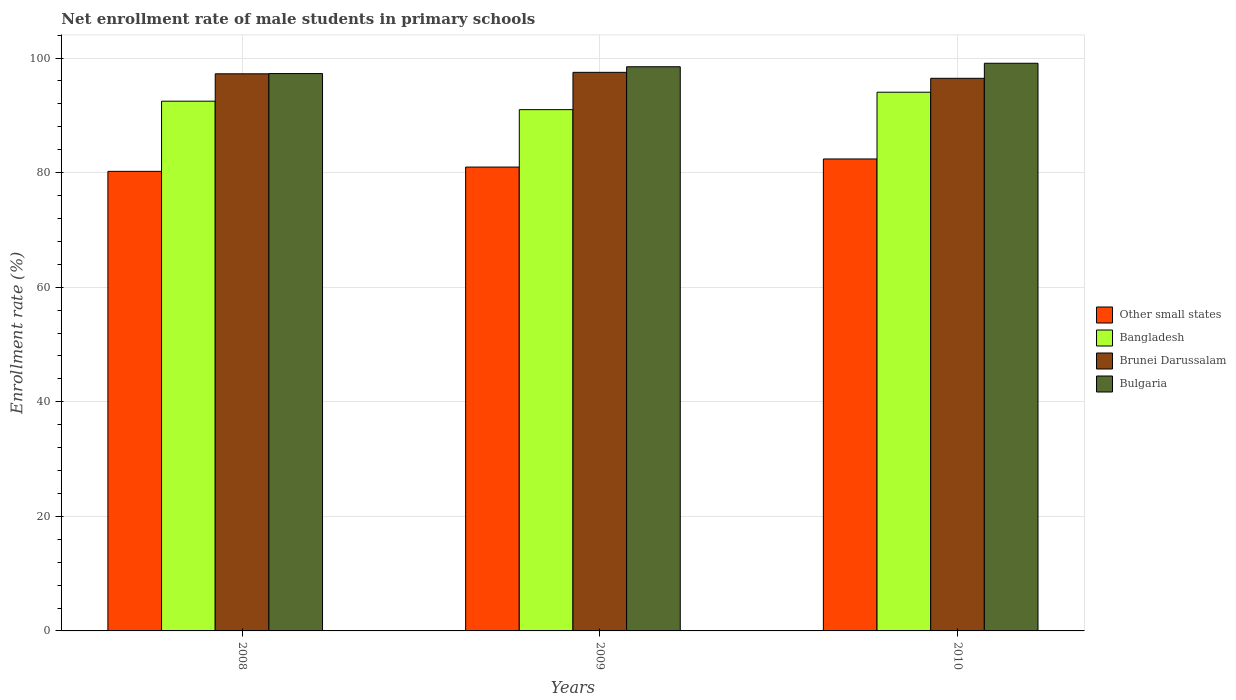How many different coloured bars are there?
Ensure brevity in your answer.  4. How many groups of bars are there?
Keep it short and to the point. 3. Are the number of bars per tick equal to the number of legend labels?
Your response must be concise. Yes. How many bars are there on the 1st tick from the right?
Ensure brevity in your answer.  4. What is the label of the 1st group of bars from the left?
Your response must be concise. 2008. What is the net enrollment rate of male students in primary schools in Bulgaria in 2009?
Give a very brief answer. 98.48. Across all years, what is the maximum net enrollment rate of male students in primary schools in Bangladesh?
Provide a succinct answer. 94.03. Across all years, what is the minimum net enrollment rate of male students in primary schools in Brunei Darussalam?
Provide a short and direct response. 96.46. In which year was the net enrollment rate of male students in primary schools in Bulgaria maximum?
Ensure brevity in your answer.  2010. In which year was the net enrollment rate of male students in primary schools in Bangladesh minimum?
Provide a short and direct response. 2009. What is the total net enrollment rate of male students in primary schools in Bulgaria in the graph?
Your response must be concise. 294.85. What is the difference between the net enrollment rate of male students in primary schools in Bulgaria in 2008 and that in 2010?
Your answer should be compact. -1.8. What is the difference between the net enrollment rate of male students in primary schools in Brunei Darussalam in 2008 and the net enrollment rate of male students in primary schools in Bulgaria in 2009?
Give a very brief answer. -1.23. What is the average net enrollment rate of male students in primary schools in Bulgaria per year?
Provide a short and direct response. 98.28. In the year 2009, what is the difference between the net enrollment rate of male students in primary schools in Bulgaria and net enrollment rate of male students in primary schools in Other small states?
Offer a terse response. 17.51. In how many years, is the net enrollment rate of male students in primary schools in Brunei Darussalam greater than 72 %?
Offer a terse response. 3. What is the ratio of the net enrollment rate of male students in primary schools in Bulgaria in 2008 to that in 2009?
Your response must be concise. 0.99. Is the difference between the net enrollment rate of male students in primary schools in Bulgaria in 2008 and 2010 greater than the difference between the net enrollment rate of male students in primary schools in Other small states in 2008 and 2010?
Make the answer very short. Yes. What is the difference between the highest and the second highest net enrollment rate of male students in primary schools in Bangladesh?
Provide a succinct answer. 1.57. What is the difference between the highest and the lowest net enrollment rate of male students in primary schools in Brunei Darussalam?
Your answer should be very brief. 1.04. In how many years, is the net enrollment rate of male students in primary schools in Bulgaria greater than the average net enrollment rate of male students in primary schools in Bulgaria taken over all years?
Ensure brevity in your answer.  2. Is the sum of the net enrollment rate of male students in primary schools in Bulgaria in 2008 and 2009 greater than the maximum net enrollment rate of male students in primary schools in Other small states across all years?
Keep it short and to the point. Yes. What does the 2nd bar from the left in 2009 represents?
Your answer should be compact. Bangladesh. What does the 1st bar from the right in 2010 represents?
Your answer should be very brief. Bulgaria. Is it the case that in every year, the sum of the net enrollment rate of male students in primary schools in Bulgaria and net enrollment rate of male students in primary schools in Bangladesh is greater than the net enrollment rate of male students in primary schools in Other small states?
Your response must be concise. Yes. How many bars are there?
Provide a succinct answer. 12. What is the difference between two consecutive major ticks on the Y-axis?
Keep it short and to the point. 20. Does the graph contain grids?
Ensure brevity in your answer.  Yes. Where does the legend appear in the graph?
Keep it short and to the point. Center right. How many legend labels are there?
Ensure brevity in your answer.  4. How are the legend labels stacked?
Provide a short and direct response. Vertical. What is the title of the graph?
Offer a very short reply. Net enrollment rate of male students in primary schools. Does "Faeroe Islands" appear as one of the legend labels in the graph?
Your response must be concise. No. What is the label or title of the X-axis?
Provide a succinct answer. Years. What is the label or title of the Y-axis?
Provide a succinct answer. Enrollment rate (%). What is the Enrollment rate (%) of Other small states in 2008?
Your answer should be compact. 80.22. What is the Enrollment rate (%) in Bangladesh in 2008?
Give a very brief answer. 92.47. What is the Enrollment rate (%) of Brunei Darussalam in 2008?
Make the answer very short. 97.25. What is the Enrollment rate (%) of Bulgaria in 2008?
Provide a succinct answer. 97.29. What is the Enrollment rate (%) in Other small states in 2009?
Offer a very short reply. 80.97. What is the Enrollment rate (%) in Bangladesh in 2009?
Provide a succinct answer. 90.99. What is the Enrollment rate (%) in Brunei Darussalam in 2009?
Provide a short and direct response. 97.5. What is the Enrollment rate (%) in Bulgaria in 2009?
Your answer should be compact. 98.48. What is the Enrollment rate (%) in Other small states in 2010?
Ensure brevity in your answer.  82.38. What is the Enrollment rate (%) in Bangladesh in 2010?
Your answer should be compact. 94.03. What is the Enrollment rate (%) of Brunei Darussalam in 2010?
Your answer should be very brief. 96.46. What is the Enrollment rate (%) in Bulgaria in 2010?
Your answer should be compact. 99.09. Across all years, what is the maximum Enrollment rate (%) of Other small states?
Make the answer very short. 82.38. Across all years, what is the maximum Enrollment rate (%) in Bangladesh?
Make the answer very short. 94.03. Across all years, what is the maximum Enrollment rate (%) of Brunei Darussalam?
Give a very brief answer. 97.5. Across all years, what is the maximum Enrollment rate (%) in Bulgaria?
Your answer should be compact. 99.09. Across all years, what is the minimum Enrollment rate (%) in Other small states?
Your answer should be very brief. 80.22. Across all years, what is the minimum Enrollment rate (%) in Bangladesh?
Provide a short and direct response. 90.99. Across all years, what is the minimum Enrollment rate (%) in Brunei Darussalam?
Ensure brevity in your answer.  96.46. Across all years, what is the minimum Enrollment rate (%) in Bulgaria?
Give a very brief answer. 97.29. What is the total Enrollment rate (%) of Other small states in the graph?
Offer a terse response. 243.57. What is the total Enrollment rate (%) in Bangladesh in the graph?
Provide a succinct answer. 277.49. What is the total Enrollment rate (%) in Brunei Darussalam in the graph?
Ensure brevity in your answer.  291.21. What is the total Enrollment rate (%) of Bulgaria in the graph?
Make the answer very short. 294.85. What is the difference between the Enrollment rate (%) in Other small states in 2008 and that in 2009?
Ensure brevity in your answer.  -0.75. What is the difference between the Enrollment rate (%) of Bangladesh in 2008 and that in 2009?
Offer a very short reply. 1.48. What is the difference between the Enrollment rate (%) in Brunei Darussalam in 2008 and that in 2009?
Keep it short and to the point. -0.26. What is the difference between the Enrollment rate (%) in Bulgaria in 2008 and that in 2009?
Your answer should be very brief. -1.19. What is the difference between the Enrollment rate (%) in Other small states in 2008 and that in 2010?
Provide a short and direct response. -2.16. What is the difference between the Enrollment rate (%) in Bangladesh in 2008 and that in 2010?
Offer a very short reply. -1.57. What is the difference between the Enrollment rate (%) in Brunei Darussalam in 2008 and that in 2010?
Your response must be concise. 0.79. What is the difference between the Enrollment rate (%) of Bulgaria in 2008 and that in 2010?
Ensure brevity in your answer.  -1.8. What is the difference between the Enrollment rate (%) of Other small states in 2009 and that in 2010?
Give a very brief answer. -1.41. What is the difference between the Enrollment rate (%) of Bangladesh in 2009 and that in 2010?
Provide a succinct answer. -3.05. What is the difference between the Enrollment rate (%) in Brunei Darussalam in 2009 and that in 2010?
Keep it short and to the point. 1.04. What is the difference between the Enrollment rate (%) of Bulgaria in 2009 and that in 2010?
Offer a very short reply. -0.61. What is the difference between the Enrollment rate (%) of Other small states in 2008 and the Enrollment rate (%) of Bangladesh in 2009?
Your response must be concise. -10.77. What is the difference between the Enrollment rate (%) in Other small states in 2008 and the Enrollment rate (%) in Brunei Darussalam in 2009?
Provide a short and direct response. -17.29. What is the difference between the Enrollment rate (%) of Other small states in 2008 and the Enrollment rate (%) of Bulgaria in 2009?
Keep it short and to the point. -18.26. What is the difference between the Enrollment rate (%) in Bangladesh in 2008 and the Enrollment rate (%) in Brunei Darussalam in 2009?
Offer a very short reply. -5.04. What is the difference between the Enrollment rate (%) of Bangladesh in 2008 and the Enrollment rate (%) of Bulgaria in 2009?
Offer a very short reply. -6.01. What is the difference between the Enrollment rate (%) of Brunei Darussalam in 2008 and the Enrollment rate (%) of Bulgaria in 2009?
Offer a very short reply. -1.23. What is the difference between the Enrollment rate (%) of Other small states in 2008 and the Enrollment rate (%) of Bangladesh in 2010?
Ensure brevity in your answer.  -13.82. What is the difference between the Enrollment rate (%) in Other small states in 2008 and the Enrollment rate (%) in Brunei Darussalam in 2010?
Your answer should be very brief. -16.24. What is the difference between the Enrollment rate (%) of Other small states in 2008 and the Enrollment rate (%) of Bulgaria in 2010?
Provide a succinct answer. -18.87. What is the difference between the Enrollment rate (%) in Bangladesh in 2008 and the Enrollment rate (%) in Brunei Darussalam in 2010?
Your answer should be compact. -3.99. What is the difference between the Enrollment rate (%) in Bangladesh in 2008 and the Enrollment rate (%) in Bulgaria in 2010?
Offer a very short reply. -6.62. What is the difference between the Enrollment rate (%) in Brunei Darussalam in 2008 and the Enrollment rate (%) in Bulgaria in 2010?
Ensure brevity in your answer.  -1.84. What is the difference between the Enrollment rate (%) of Other small states in 2009 and the Enrollment rate (%) of Bangladesh in 2010?
Your answer should be very brief. -13.07. What is the difference between the Enrollment rate (%) in Other small states in 2009 and the Enrollment rate (%) in Brunei Darussalam in 2010?
Your answer should be compact. -15.49. What is the difference between the Enrollment rate (%) in Other small states in 2009 and the Enrollment rate (%) in Bulgaria in 2010?
Offer a terse response. -18.12. What is the difference between the Enrollment rate (%) in Bangladesh in 2009 and the Enrollment rate (%) in Brunei Darussalam in 2010?
Offer a very short reply. -5.47. What is the difference between the Enrollment rate (%) of Bangladesh in 2009 and the Enrollment rate (%) of Bulgaria in 2010?
Your answer should be compact. -8.1. What is the difference between the Enrollment rate (%) in Brunei Darussalam in 2009 and the Enrollment rate (%) in Bulgaria in 2010?
Give a very brief answer. -1.58. What is the average Enrollment rate (%) in Other small states per year?
Ensure brevity in your answer.  81.19. What is the average Enrollment rate (%) of Bangladesh per year?
Offer a terse response. 92.5. What is the average Enrollment rate (%) in Brunei Darussalam per year?
Your answer should be compact. 97.07. What is the average Enrollment rate (%) in Bulgaria per year?
Offer a terse response. 98.28. In the year 2008, what is the difference between the Enrollment rate (%) in Other small states and Enrollment rate (%) in Bangladesh?
Keep it short and to the point. -12.25. In the year 2008, what is the difference between the Enrollment rate (%) in Other small states and Enrollment rate (%) in Brunei Darussalam?
Provide a short and direct response. -17.03. In the year 2008, what is the difference between the Enrollment rate (%) in Other small states and Enrollment rate (%) in Bulgaria?
Ensure brevity in your answer.  -17.07. In the year 2008, what is the difference between the Enrollment rate (%) of Bangladesh and Enrollment rate (%) of Brunei Darussalam?
Your answer should be very brief. -4.78. In the year 2008, what is the difference between the Enrollment rate (%) of Bangladesh and Enrollment rate (%) of Bulgaria?
Ensure brevity in your answer.  -4.82. In the year 2008, what is the difference between the Enrollment rate (%) in Brunei Darussalam and Enrollment rate (%) in Bulgaria?
Offer a terse response. -0.04. In the year 2009, what is the difference between the Enrollment rate (%) in Other small states and Enrollment rate (%) in Bangladesh?
Provide a succinct answer. -10.02. In the year 2009, what is the difference between the Enrollment rate (%) of Other small states and Enrollment rate (%) of Brunei Darussalam?
Your response must be concise. -16.54. In the year 2009, what is the difference between the Enrollment rate (%) of Other small states and Enrollment rate (%) of Bulgaria?
Ensure brevity in your answer.  -17.51. In the year 2009, what is the difference between the Enrollment rate (%) in Bangladesh and Enrollment rate (%) in Brunei Darussalam?
Your answer should be compact. -6.51. In the year 2009, what is the difference between the Enrollment rate (%) of Bangladesh and Enrollment rate (%) of Bulgaria?
Provide a succinct answer. -7.49. In the year 2009, what is the difference between the Enrollment rate (%) of Brunei Darussalam and Enrollment rate (%) of Bulgaria?
Offer a very short reply. -0.97. In the year 2010, what is the difference between the Enrollment rate (%) in Other small states and Enrollment rate (%) in Bangladesh?
Your answer should be compact. -11.65. In the year 2010, what is the difference between the Enrollment rate (%) of Other small states and Enrollment rate (%) of Brunei Darussalam?
Offer a terse response. -14.08. In the year 2010, what is the difference between the Enrollment rate (%) of Other small states and Enrollment rate (%) of Bulgaria?
Provide a succinct answer. -16.71. In the year 2010, what is the difference between the Enrollment rate (%) of Bangladesh and Enrollment rate (%) of Brunei Darussalam?
Your response must be concise. -2.43. In the year 2010, what is the difference between the Enrollment rate (%) of Bangladesh and Enrollment rate (%) of Bulgaria?
Provide a short and direct response. -5.05. In the year 2010, what is the difference between the Enrollment rate (%) of Brunei Darussalam and Enrollment rate (%) of Bulgaria?
Provide a short and direct response. -2.63. What is the ratio of the Enrollment rate (%) of Bangladesh in 2008 to that in 2009?
Offer a terse response. 1.02. What is the ratio of the Enrollment rate (%) of Bulgaria in 2008 to that in 2009?
Your answer should be very brief. 0.99. What is the ratio of the Enrollment rate (%) of Other small states in 2008 to that in 2010?
Offer a terse response. 0.97. What is the ratio of the Enrollment rate (%) in Bangladesh in 2008 to that in 2010?
Ensure brevity in your answer.  0.98. What is the ratio of the Enrollment rate (%) in Brunei Darussalam in 2008 to that in 2010?
Keep it short and to the point. 1.01. What is the ratio of the Enrollment rate (%) of Bulgaria in 2008 to that in 2010?
Make the answer very short. 0.98. What is the ratio of the Enrollment rate (%) in Other small states in 2009 to that in 2010?
Offer a terse response. 0.98. What is the ratio of the Enrollment rate (%) in Bangladesh in 2009 to that in 2010?
Your answer should be very brief. 0.97. What is the ratio of the Enrollment rate (%) of Brunei Darussalam in 2009 to that in 2010?
Offer a terse response. 1.01. What is the ratio of the Enrollment rate (%) of Bulgaria in 2009 to that in 2010?
Offer a very short reply. 0.99. What is the difference between the highest and the second highest Enrollment rate (%) of Other small states?
Offer a very short reply. 1.41. What is the difference between the highest and the second highest Enrollment rate (%) in Bangladesh?
Your answer should be very brief. 1.57. What is the difference between the highest and the second highest Enrollment rate (%) of Brunei Darussalam?
Your answer should be very brief. 0.26. What is the difference between the highest and the second highest Enrollment rate (%) in Bulgaria?
Ensure brevity in your answer.  0.61. What is the difference between the highest and the lowest Enrollment rate (%) in Other small states?
Offer a very short reply. 2.16. What is the difference between the highest and the lowest Enrollment rate (%) in Bangladesh?
Ensure brevity in your answer.  3.05. What is the difference between the highest and the lowest Enrollment rate (%) of Brunei Darussalam?
Provide a succinct answer. 1.04. What is the difference between the highest and the lowest Enrollment rate (%) in Bulgaria?
Your answer should be compact. 1.8. 